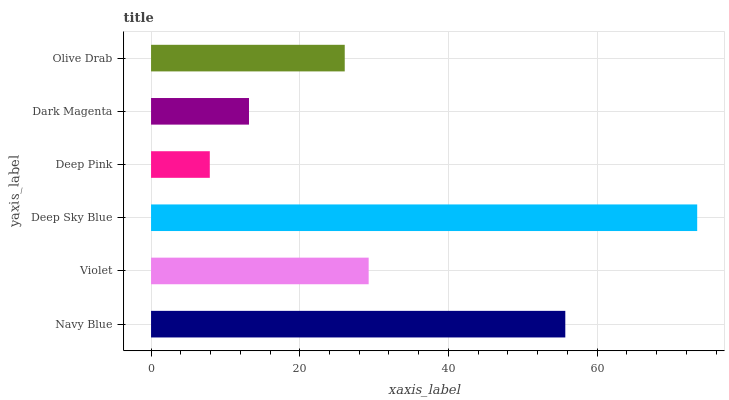Is Deep Pink the minimum?
Answer yes or no. Yes. Is Deep Sky Blue the maximum?
Answer yes or no. Yes. Is Violet the minimum?
Answer yes or no. No. Is Violet the maximum?
Answer yes or no. No. Is Navy Blue greater than Violet?
Answer yes or no. Yes. Is Violet less than Navy Blue?
Answer yes or no. Yes. Is Violet greater than Navy Blue?
Answer yes or no. No. Is Navy Blue less than Violet?
Answer yes or no. No. Is Violet the high median?
Answer yes or no. Yes. Is Olive Drab the low median?
Answer yes or no. Yes. Is Deep Pink the high median?
Answer yes or no. No. Is Dark Magenta the low median?
Answer yes or no. No. 